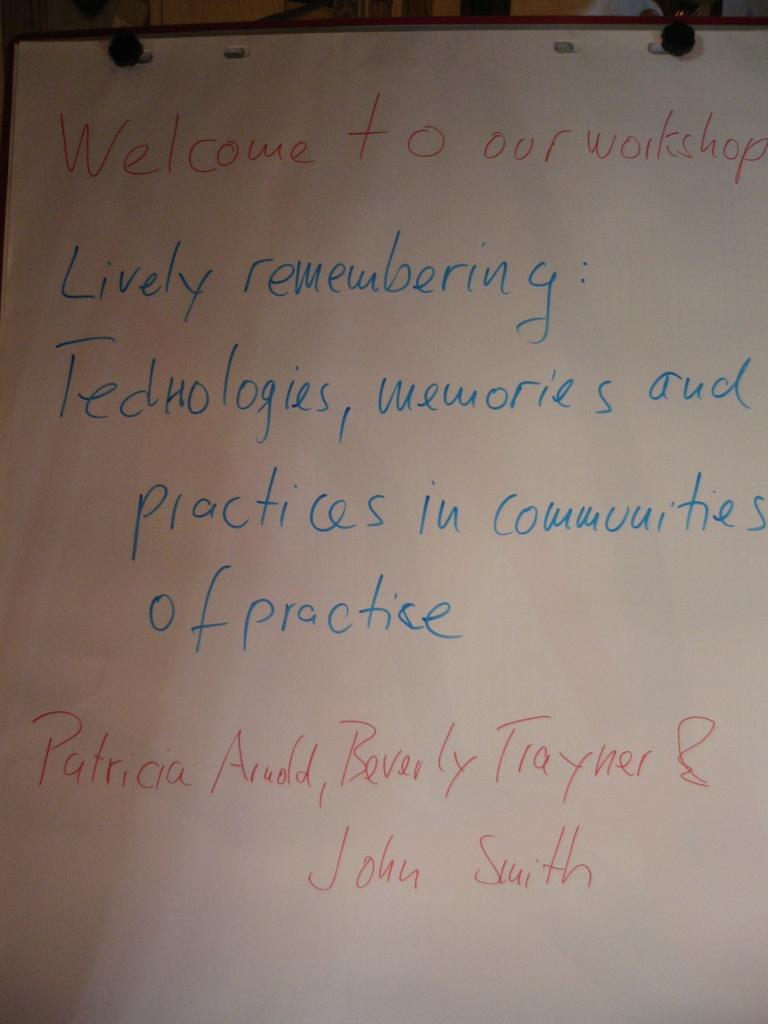Provide a one-sentence caption for the provided image. A board has writing that welcomes people to a workshop. 